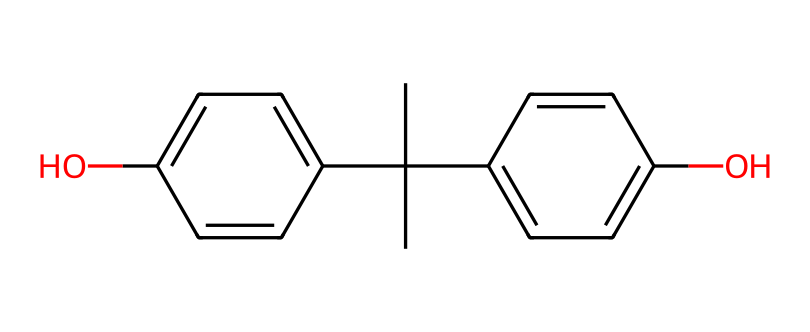What is the molecular formula of bisphenol A? To determine the molecular formula, count the number of carbon (C), hydrogen (H), and oxygen (O) atoms in the structure represented by the SMILES. The structure has 15 carbon atoms, 16 hydrogen atoms, and 2 oxygen atoms. Thus, the formula is C15H16O2.
Answer: C15H16O2 How many hydroxyl groups are present in bisphenol A? By examining the structure, identify the -OH (hydroxyl) groups. In the provided SMILES representation, there are two -OH groups attached to the aromatic rings, indicating that there are two hydroxyl groups.
Answer: 2 What type of compound is bisphenol A classified as based on its structure? Bisphenol A has two phenolic rings connected by a carbon chain, indicating that it is a phenolic compound. Phenolic compounds are known for containing hydroxyl (-OH) groups bonded to aromatic structures.
Answer: phenolic Is bisphenol A an example of a coordination compound? Coordination compounds typically involve metal atoms or ions bonded to ligands. Bisphenol A does not contain any metal coordination but rather features covalent bonding between carbon and hydroxyl functions. Therefore, it is not a coordination compound.
Answer: no How many rings are present in the structure of bisphenol A? Count the distinct cyclic structures in the provided SMILES. In bisphenol A, there are two aromatic rings seen in the structure, confirming that two rings are present.
Answer: 2 Are there any double bonds in the structure of bisphenol A? Analyze the structure for the presence of double bonds. Observe that the two aromatic rings contain alternating single and double bonds, which are characteristic of conjugated systems in aromatic chemistry, confirming that double bonds are present.
Answer: yes 